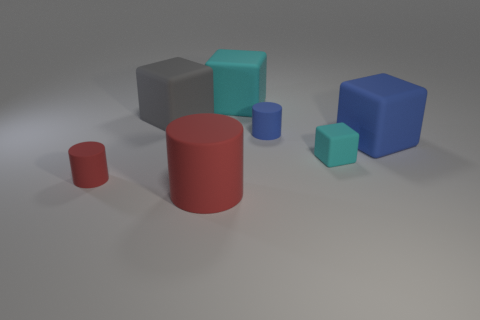Subtract all green blocks. How many red cylinders are left? 2 Subtract all big blue matte cubes. How many cubes are left? 3 Subtract 1 blocks. How many blocks are left? 3 Subtract all blue blocks. How many blocks are left? 3 Add 2 tiny blue rubber cylinders. How many objects exist? 9 Subtract all cylinders. How many objects are left? 4 Subtract all purple cubes. Subtract all yellow balls. How many cubes are left? 4 Subtract 0 green cubes. How many objects are left? 7 Subtract all small metal spheres. Subtract all tiny cyan matte blocks. How many objects are left? 6 Add 5 small matte objects. How many small matte objects are left? 8 